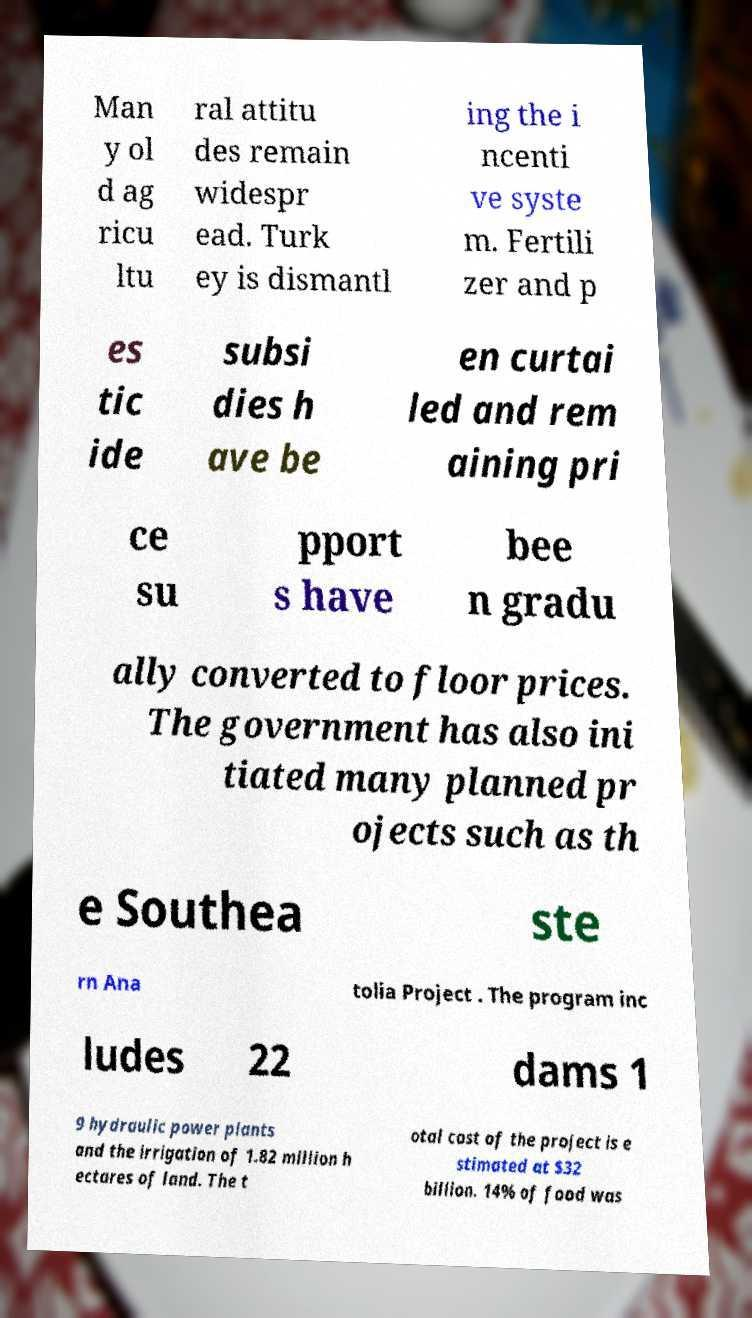Could you extract and type out the text from this image? Man y ol d ag ricu ltu ral attitu des remain widespr ead. Turk ey is dismantl ing the i ncenti ve syste m. Fertili zer and p es tic ide subsi dies h ave be en curtai led and rem aining pri ce su pport s have bee n gradu ally converted to floor prices. The government has also ini tiated many planned pr ojects such as th e Southea ste rn Ana tolia Project . The program inc ludes 22 dams 1 9 hydraulic power plants and the irrigation of 1.82 million h ectares of land. The t otal cost of the project is e stimated at $32 billion. 14% of food was 